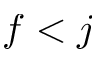Convert formula to latex. <formula><loc_0><loc_0><loc_500><loc_500>f < j</formula> 